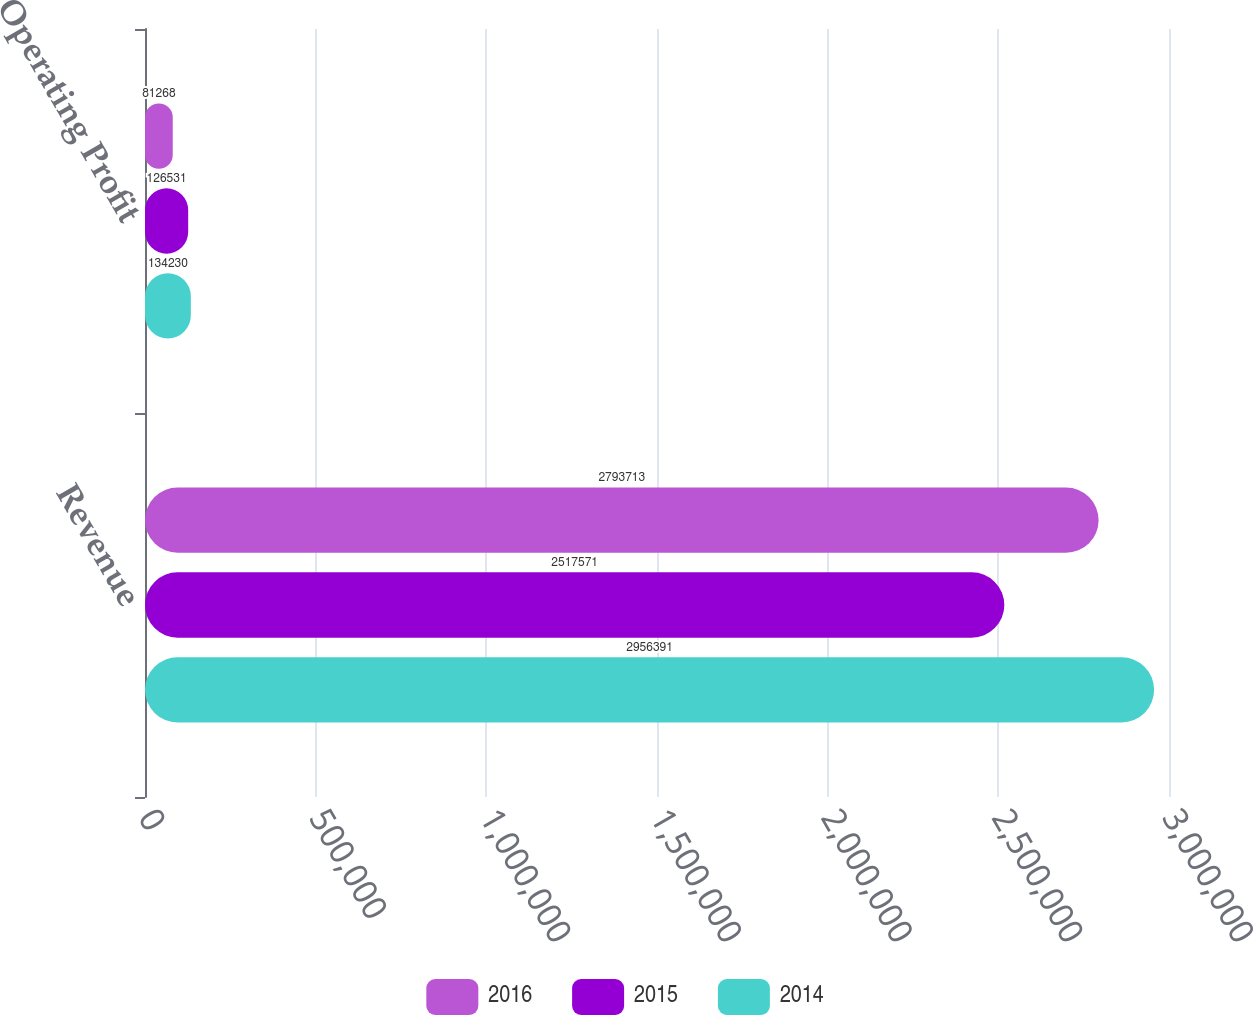<chart> <loc_0><loc_0><loc_500><loc_500><stacked_bar_chart><ecel><fcel>Revenue<fcel>Operating Profit<nl><fcel>2016<fcel>2.79371e+06<fcel>81268<nl><fcel>2015<fcel>2.51757e+06<fcel>126531<nl><fcel>2014<fcel>2.95639e+06<fcel>134230<nl></chart> 